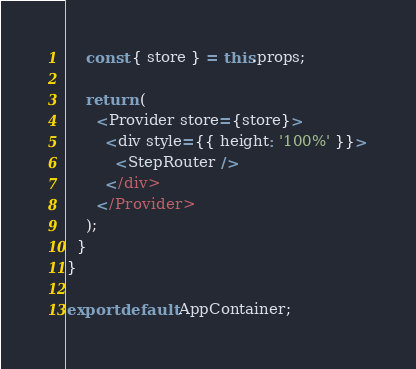Convert code to text. <code><loc_0><loc_0><loc_500><loc_500><_JavaScript_>    const { store } = this.props;

    return (
      <Provider store={store}>
        <div style={{ height: '100%' }}>
          <StepRouter />
        </div>
      </Provider>
    );
  }
}

export default AppContainer;
</code> 